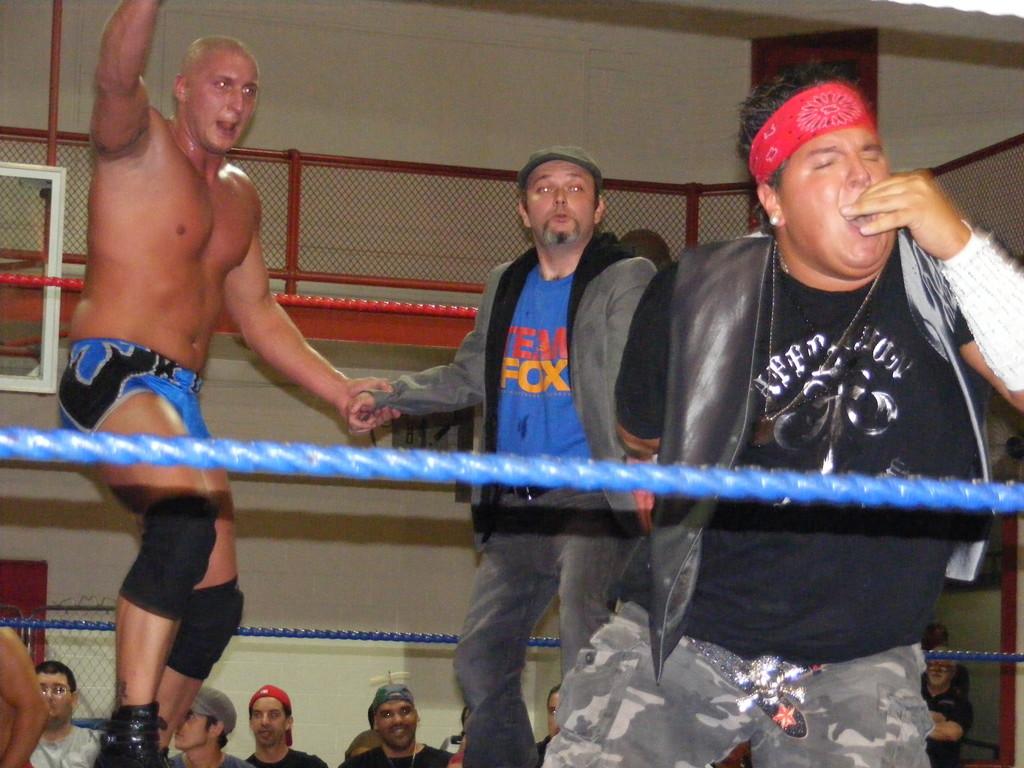What is on the man's shirt that the wrestler is holding hands with?
Offer a terse response. Team fox. 